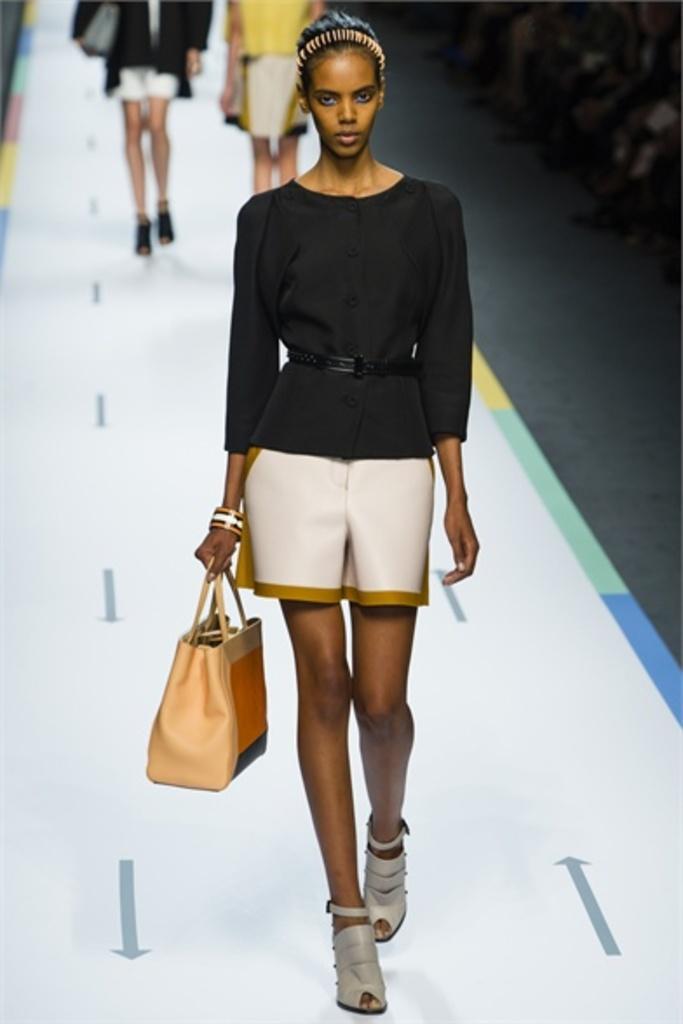In one or two sentences, can you explain what this image depicts? a person is walking on the ramp holding a bag. behind her there are 2 more people walking. 